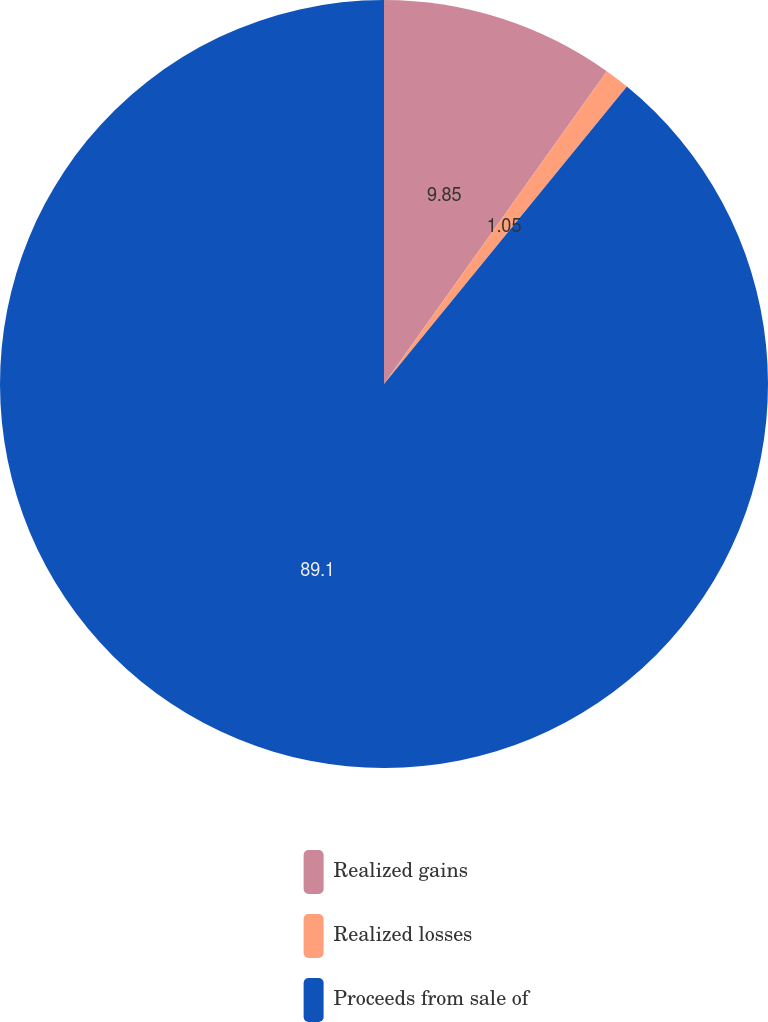Convert chart to OTSL. <chart><loc_0><loc_0><loc_500><loc_500><pie_chart><fcel>Realized gains<fcel>Realized losses<fcel>Proceeds from sale of<nl><fcel>9.85%<fcel>1.05%<fcel>89.1%<nl></chart> 